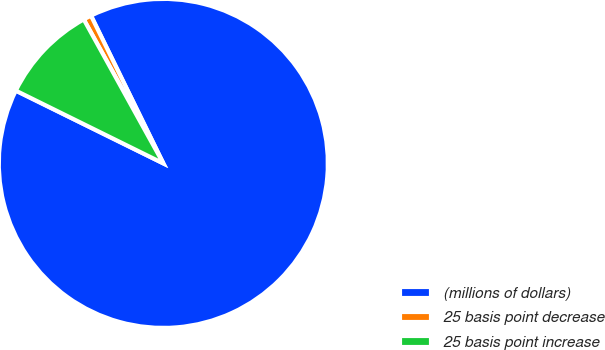Convert chart. <chart><loc_0><loc_0><loc_500><loc_500><pie_chart><fcel>(millions of dollars)<fcel>25 basis point decrease<fcel>25 basis point increase<nl><fcel>89.54%<fcel>0.79%<fcel>9.67%<nl></chart> 